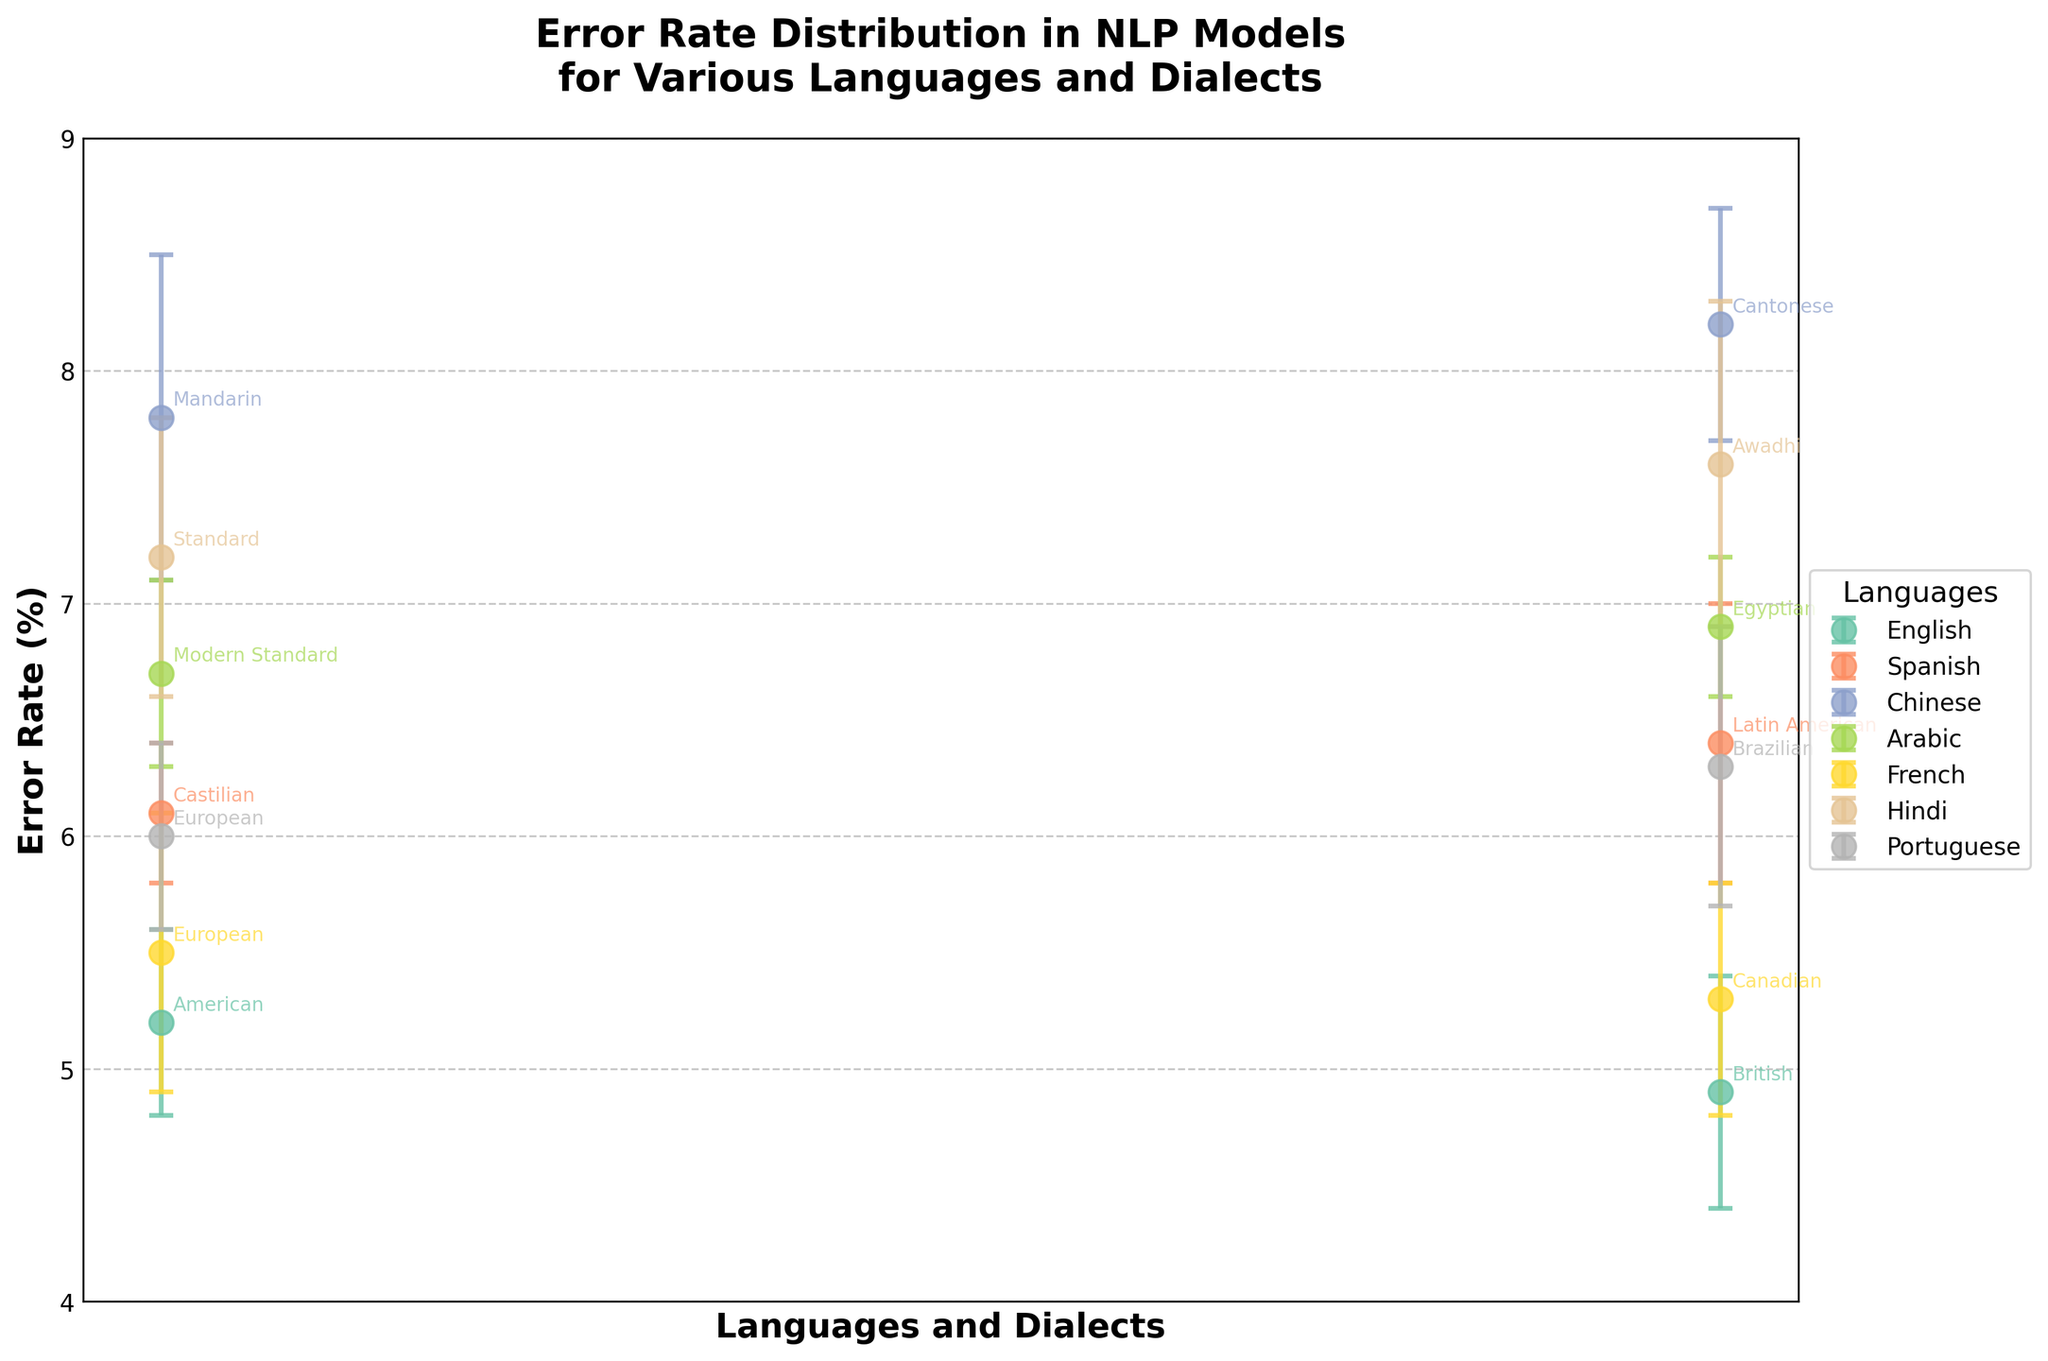what is the title of the figure? The title is the text displayed at the top of the plot, providing an overall description of the figure's content. In this case, the title is "Error Rate Distribution in NLP Models for Various Languages and Dialects".
Answer: Error Rate Distribution in NLP Models for Various Languages and Dialects Which language and dialect have the highest error rate? To determine this, look at all the points on the plot and their error rates. The highest point corresponds to "Chinese, Cantonese" with an error rate of 8.2%.
Answer: Chinese, Cantonese Which language and dialect have the smallest error margin? The error margin can be identified by looking at the error bars. The smallest error margin is 0.3, which corresponds to both "Spanish, Castilian" and "Arabic, Egyptian".
Answer: Spanish, Castilian and Arabic, Egyptian What is the difference in error rate between Mandarin and Cantonese dialects of Chinese? The error rate for Mandarin is 7.8% and for Cantonese is 8.2%. Subtract the two values: 8.2% - 7.8% = 0.4%.
Answer: 0.4% Which dialect has a lower error rate, Standard Hindi or Awadhi Hindi? By comparing the points for Standard Hindi (7.2%) and Awadhi Hindi (7.6%), we see that Standard Hindi has a lower error rate.
Answer: Standard Hindi What is the average error rate across all Spanish dialects? The error rates for Spanish dialects are 6.1% and 6.4%. The average is calculated as (6.1 + 6.4)/2 = 6.25%.
Answer: 6.25% How do the error rates of American and British English compare? The error rate for American English is 5.2% and for British English is 4.9%. British English has a lower error rate than American English.
Answer: British English Which language group, French or Portuguese, has a higher average error rate? French dialects have error rates of 5.5% and 5.3%, averaging (5.5 + 5.3)/2 = 5.4%. Portuguese dialects have error rates of 6.0% and 6.3%, averaging (6.0 + 6.3)/2 = 6.15%. Portuguese has the higher average error rate.
Answer: Portuguese What is the overall range of error rates observed in the plot, across all languages and dialects? The lowest error rate is 4.9% (British English) and the highest is 8.2% (Cantonese Chinese). The range is 8.2% - 4.9% = 3.3%.
Answer: 3.3% 